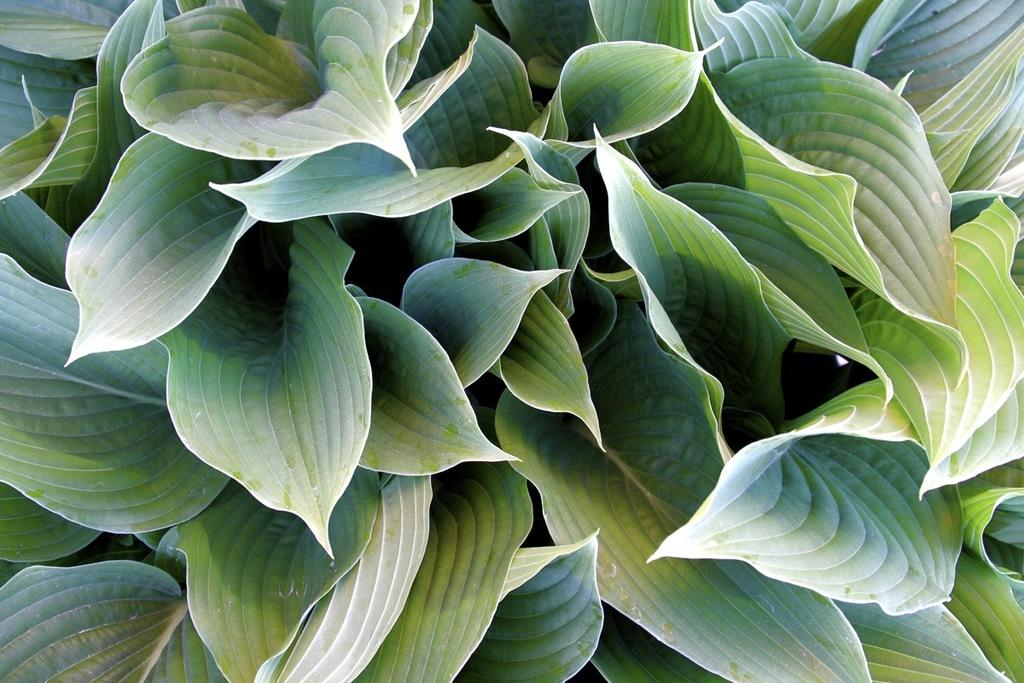What type of vegetation can be seen in the image? There are leaves in the image. How many cobwebs are visible in the image? There are no cobwebs present in the image; it only features leaves. What time of day is depicted in the image? The time of day cannot be determined from the image, as it only shows leaves. 